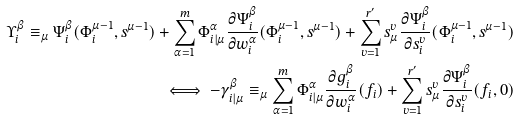<formula> <loc_0><loc_0><loc_500><loc_500>\Upsilon _ { i } ^ { \beta } \equiv _ { \mu } \Psi _ { i } ^ { \beta } ( \Phi _ { i } ^ { \mu - 1 } , s ^ { \mu - 1 } ) + \sum _ { \alpha = 1 } ^ { m } \Phi _ { i | \mu } ^ { \alpha } \frac { \partial \Psi _ { i } ^ { \beta } } { \partial w _ { i } ^ { \alpha } } ( \Phi _ { i } ^ { \mu - 1 } , s ^ { \mu - 1 } ) + \sum _ { v = 1 } ^ { r ^ { \prime } } s _ { \mu } ^ { v } \frac { \partial \Psi _ { i } ^ { \beta } } { \partial s _ { i } ^ { v } } ( \Phi _ { i } ^ { \mu - 1 } , s ^ { \mu - 1 } ) \\ \iff - \gamma _ { i | \mu } ^ { \beta } \equiv _ { \mu } \sum _ { \alpha = 1 } ^ { m } \Phi _ { i | \mu } ^ { \alpha } \frac { \partial g _ { i } ^ { \beta } } { \partial w _ { i } ^ { \alpha } } ( f _ { i } ) + \sum _ { v = 1 } ^ { r ^ { \prime } } s _ { \mu } ^ { v } \frac { \partial \Psi _ { i } ^ { \beta } } { \partial s _ { i } ^ { v } } ( f _ { i } , 0 )</formula> 